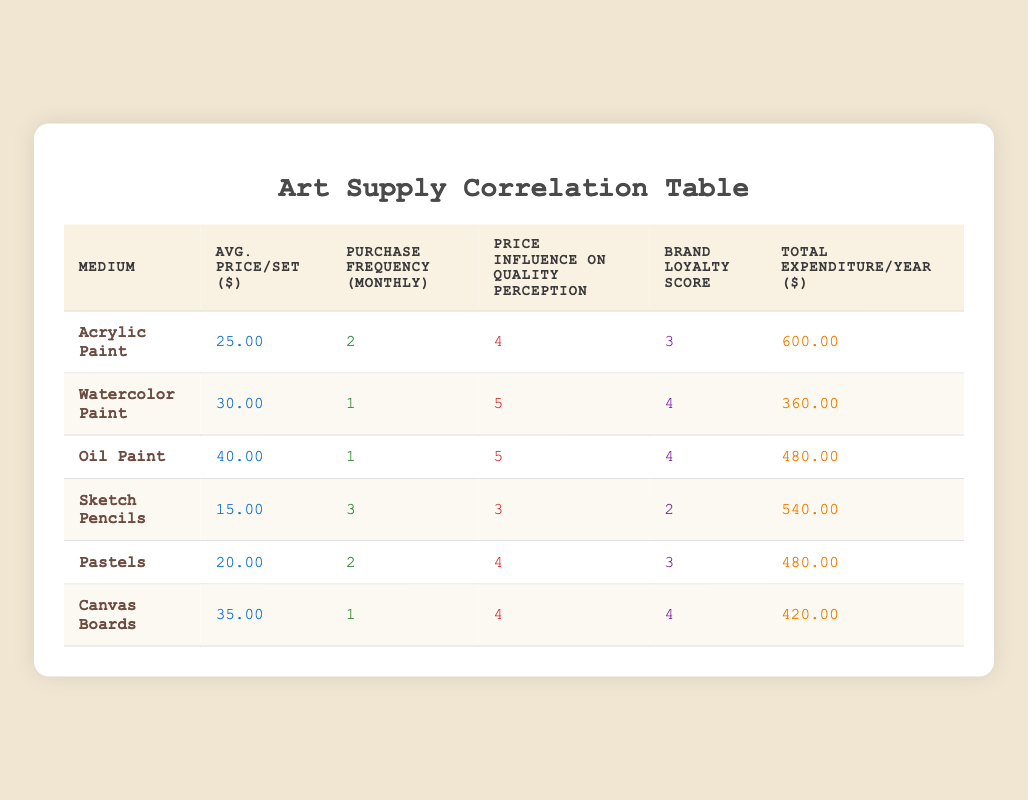What is the average price per set of watercolor paint? The table lists the average price per set for watercolor paint as 30.00.
Answer: 30.00 How many medium types have a brand loyalty score of 4? By reviewing the table, the mediums with a brand loyalty score of 4 are watercolor paint, oil paint, and canvas boards. There are 3 such mediums.
Answer: 3 What is the total expenditure for acrylic paint over a year? The table shows that the total expenditure per year for acrylic paint is 600.00.
Answer: 600.00 Which medium has the highest influence of price on quality perception? Comparing the influence scores, both watercolor paint and oil paint have the highest influence score of 5.
Answer: Watercolor paint and oil paint What is the difference in average price per set between oil paint and sketch pencils? The average price per set for oil paint is 40.00, and for sketch pencils, it is 15.00. The difference is 40.00 - 15.00 = 25.00.
Answer: 25.00 Are there any mediums that have a purchase frequency of more than 2 per month? The table shows that sketch pencils have a purchase frequency of 3, which is greater than 2. Therefore, yes, there is.
Answer: Yes Which medium type has the lowest total expenditure per year? Upon checking, watercolor paint has the lowest total expenditure per year at 360.00.
Answer: Watercolor paint What is the average influence of price on quality perception across all mediums? To find the average, sum the influence scores: 4 + 5 + 5 + 3 + 4 + 4 = 25. Divide by the number of mediums (6), so 25/6 = 4.17.
Answer: 4.17 Identify the medium with the highest average price per set and its corresponding total expenditure. The medium with the highest average price per set is oil paint at 40.00, and its total expenditure per year is 480.00.
Answer: Oil paint, 480.00 